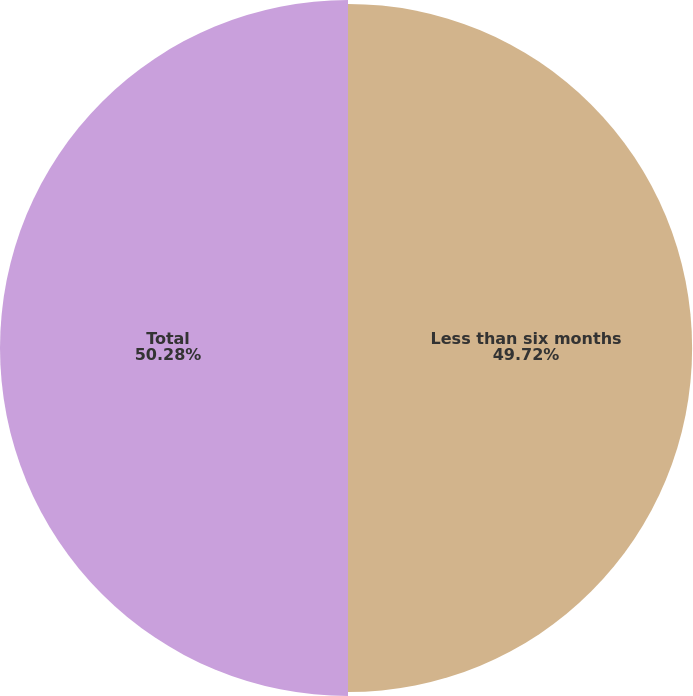Convert chart to OTSL. <chart><loc_0><loc_0><loc_500><loc_500><pie_chart><fcel>Less than six months<fcel>Total<nl><fcel>49.72%<fcel>50.28%<nl></chart> 